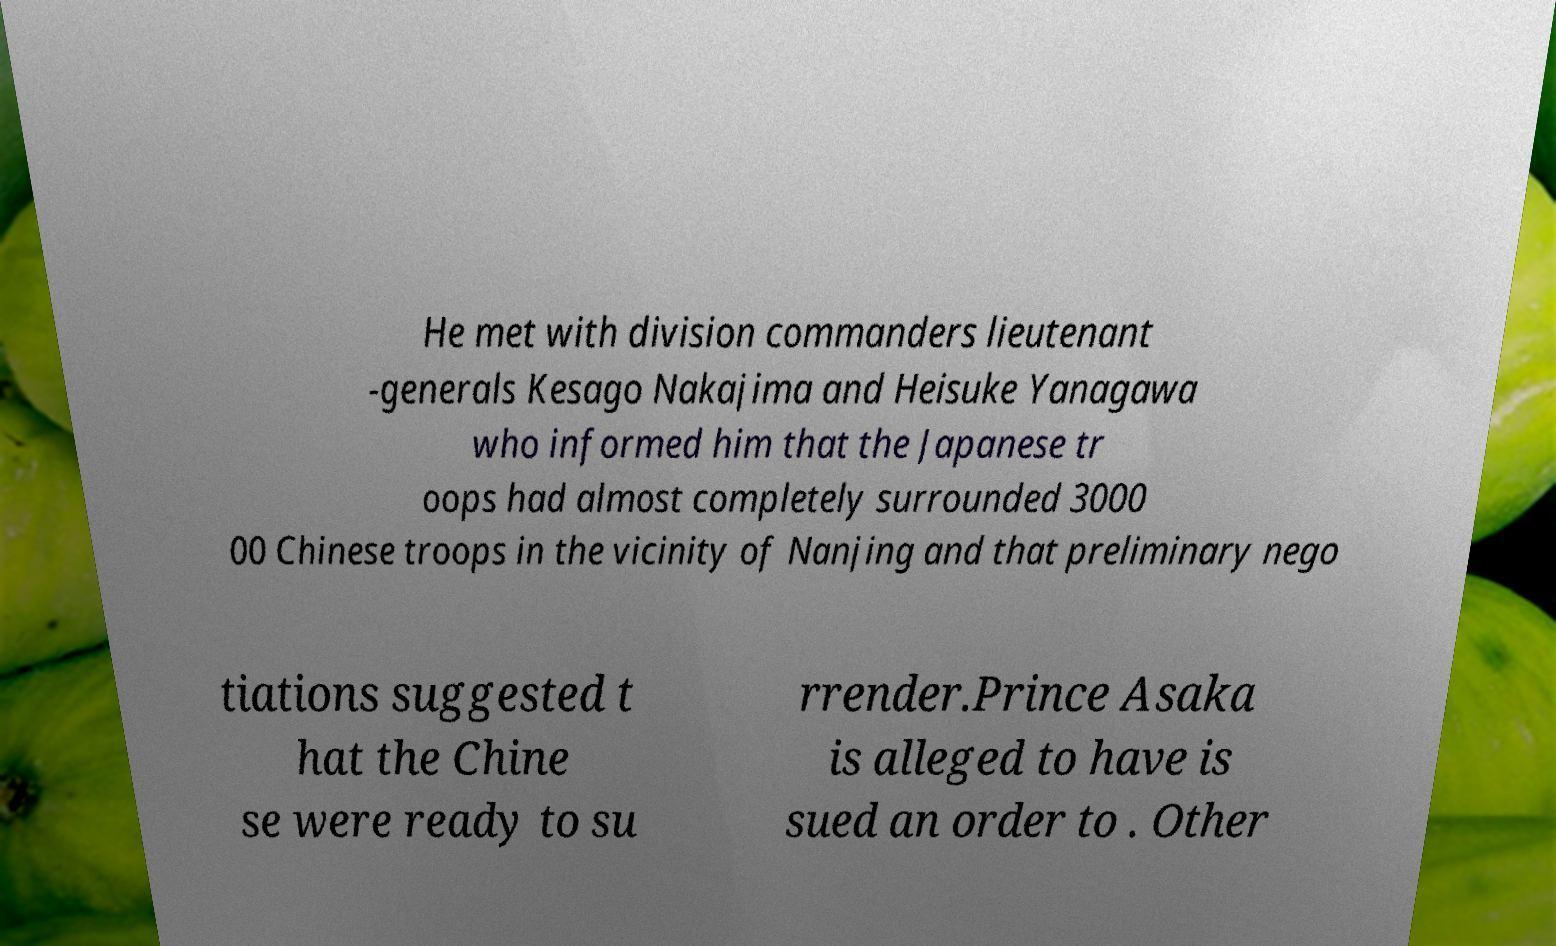Could you assist in decoding the text presented in this image and type it out clearly? He met with division commanders lieutenant -generals Kesago Nakajima and Heisuke Yanagawa who informed him that the Japanese tr oops had almost completely surrounded 3000 00 Chinese troops in the vicinity of Nanjing and that preliminary nego tiations suggested t hat the Chine se were ready to su rrender.Prince Asaka is alleged to have is sued an order to . Other 